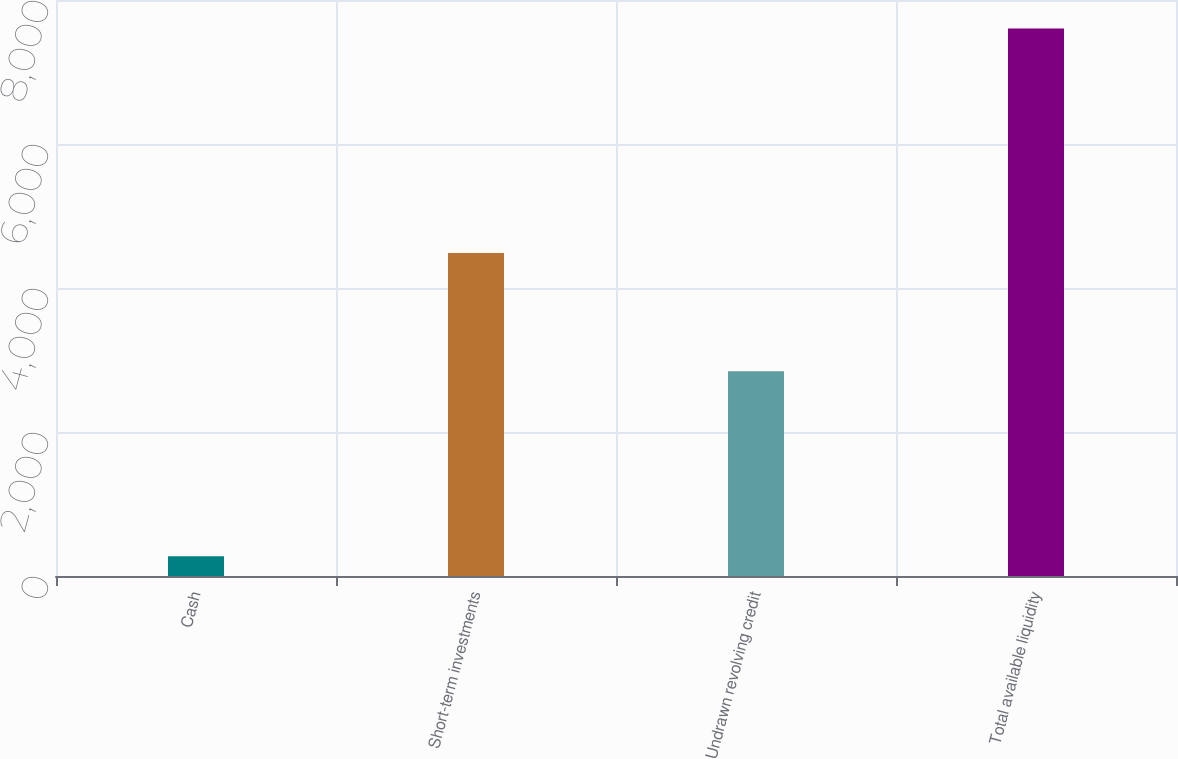Convert chart to OTSL. <chart><loc_0><loc_0><loc_500><loc_500><bar_chart><fcel>Cash<fcel>Short-term investments<fcel>Undrawn revolving credit<fcel>Total available liquidity<nl><fcel>275<fcel>4485<fcel>2843<fcel>7603<nl></chart> 